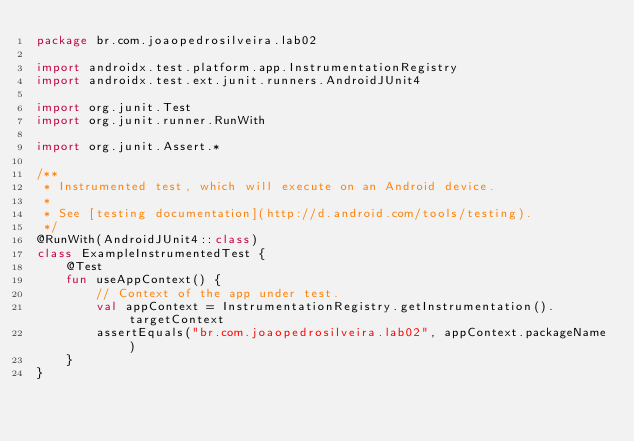Convert code to text. <code><loc_0><loc_0><loc_500><loc_500><_Kotlin_>package br.com.joaopedrosilveira.lab02

import androidx.test.platform.app.InstrumentationRegistry
import androidx.test.ext.junit.runners.AndroidJUnit4

import org.junit.Test
import org.junit.runner.RunWith

import org.junit.Assert.*

/**
 * Instrumented test, which will execute on an Android device.
 *
 * See [testing documentation](http://d.android.com/tools/testing).
 */
@RunWith(AndroidJUnit4::class)
class ExampleInstrumentedTest {
    @Test
    fun useAppContext() {
        // Context of the app under test.
        val appContext = InstrumentationRegistry.getInstrumentation().targetContext
        assertEquals("br.com.joaopedrosilveira.lab02", appContext.packageName)
    }
}</code> 